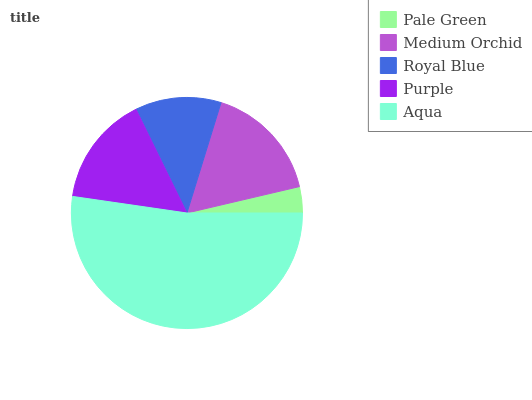Is Pale Green the minimum?
Answer yes or no. Yes. Is Aqua the maximum?
Answer yes or no. Yes. Is Medium Orchid the minimum?
Answer yes or no. No. Is Medium Orchid the maximum?
Answer yes or no. No. Is Medium Orchid greater than Pale Green?
Answer yes or no. Yes. Is Pale Green less than Medium Orchid?
Answer yes or no. Yes. Is Pale Green greater than Medium Orchid?
Answer yes or no. No. Is Medium Orchid less than Pale Green?
Answer yes or no. No. Is Purple the high median?
Answer yes or no. Yes. Is Purple the low median?
Answer yes or no. Yes. Is Royal Blue the high median?
Answer yes or no. No. Is Pale Green the low median?
Answer yes or no. No. 